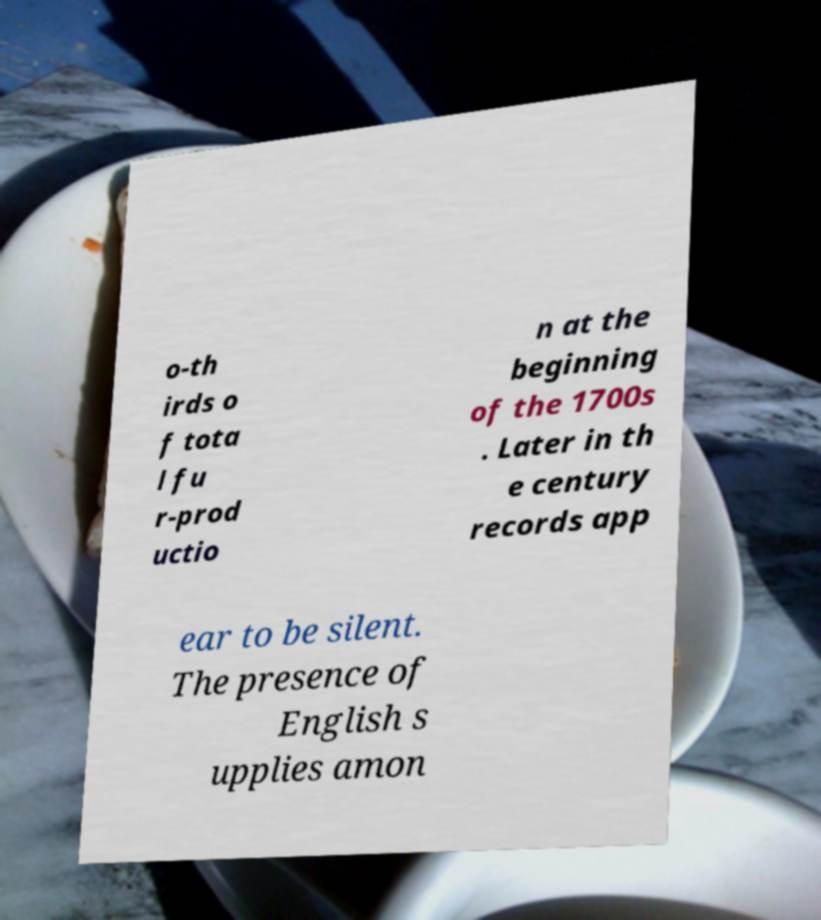Please read and relay the text visible in this image. What does it say? o-th irds o f tota l fu r-prod uctio n at the beginning of the 1700s . Later in th e century records app ear to be silent. The presence of English s upplies amon 